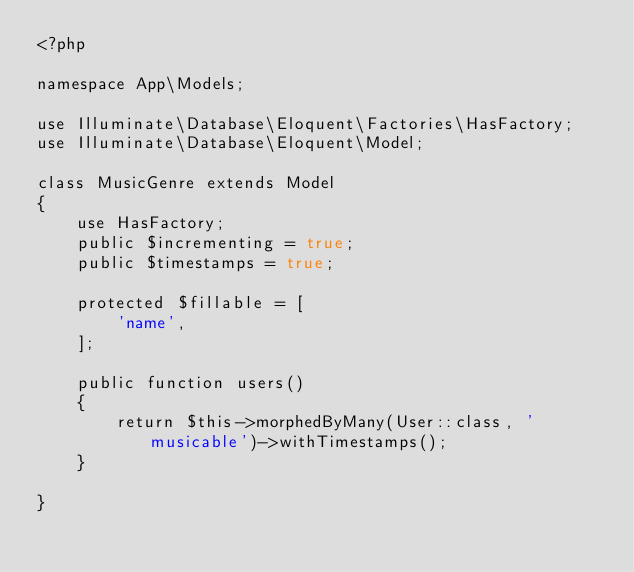Convert code to text. <code><loc_0><loc_0><loc_500><loc_500><_PHP_><?php

namespace App\Models;

use Illuminate\Database\Eloquent\Factories\HasFactory;
use Illuminate\Database\Eloquent\Model;

class MusicGenre extends Model
{
    use HasFactory;
    public $incrementing = true;
    public $timestamps = true;

    protected $fillable = [
        'name',
    ];

    public function users()
    {
        return $this->morphedByMany(User::class, 'musicable')->withTimestamps();
    }

}
</code> 